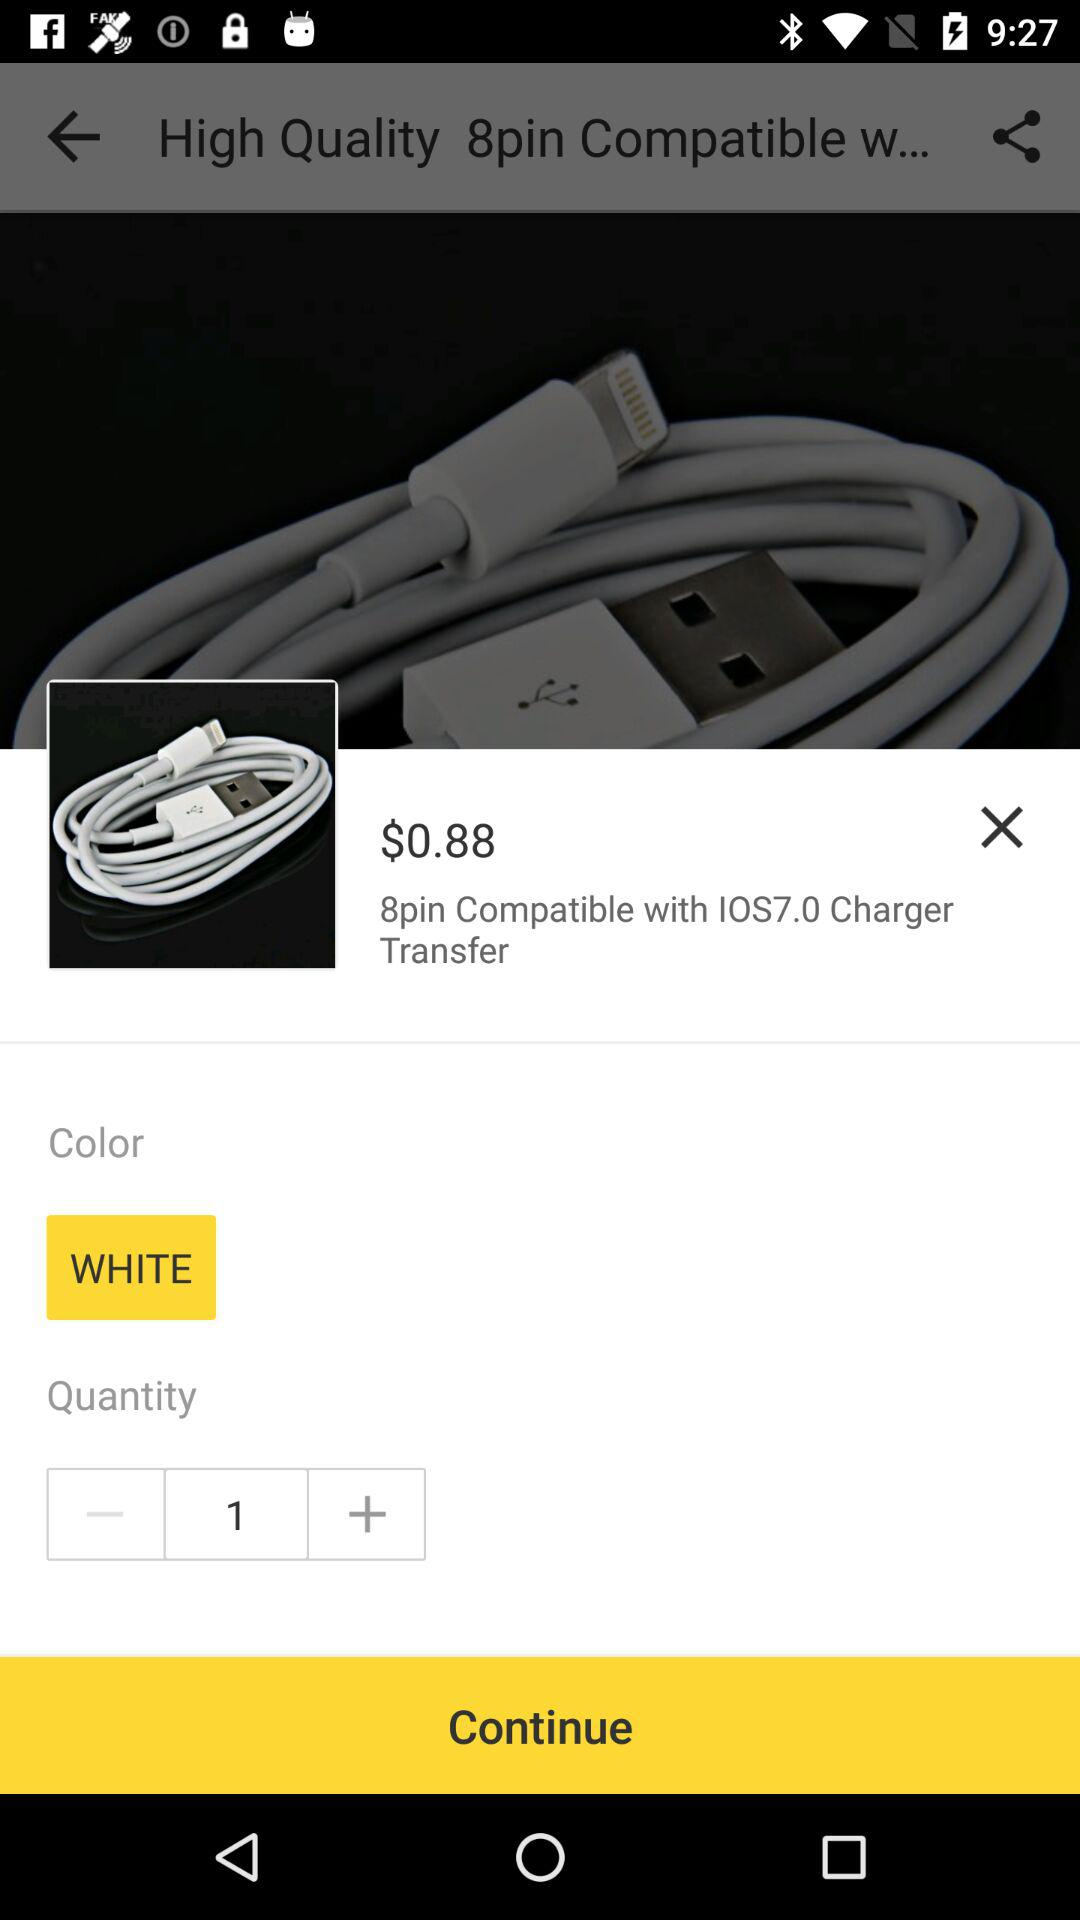What's the color of the charger? The color of the charger is white. 